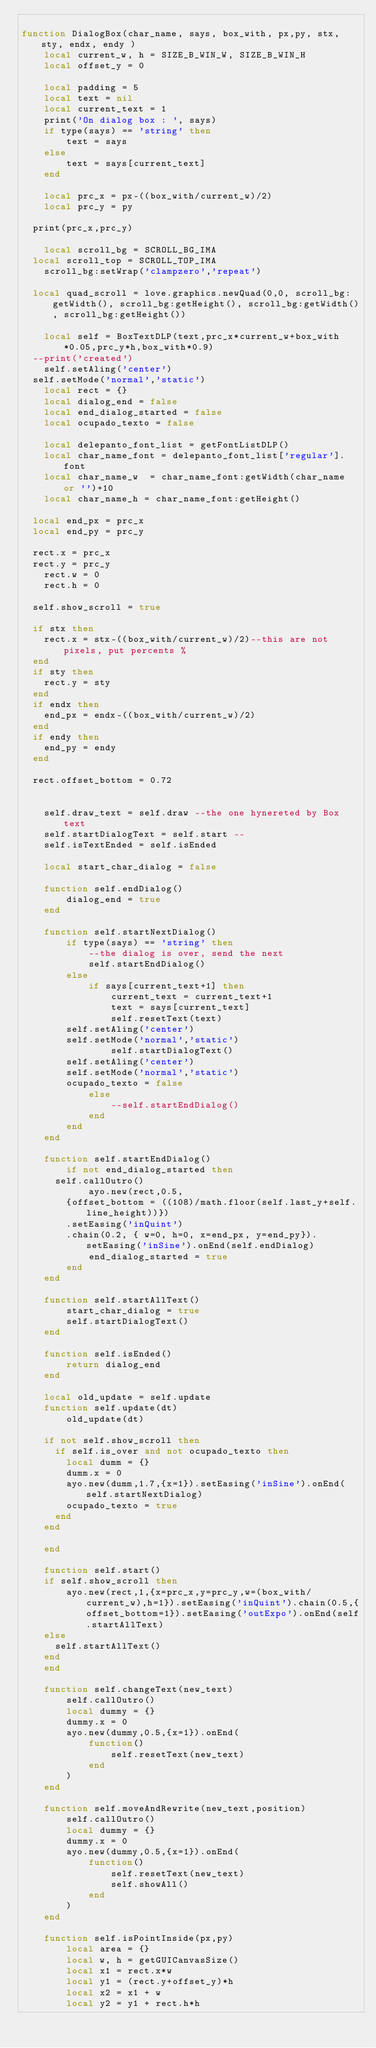Convert code to text. <code><loc_0><loc_0><loc_500><loc_500><_Lua_>
function DialogBox(char_name, says, box_with, px,py, stx, sty, endx, endy )
    local current_w, h = SIZE_B_WIN_W, SIZE_B_WIN_H
    local offset_y = 0
    
    local padding = 5
    local text = nil
    local current_text = 1
    print('On dialog box : ', says)
    if type(says) == 'string' then
        text = says
    else
        text = says[current_text]
    end
    
    local prc_x = px-((box_with/current_w)/2)
    local prc_y = py
    
	print(prc_x,prc_y)
	
    local scroll_bg = SCROLL_BG_IMA
	local scroll_top = SCROLL_TOP_IMA
    scroll_bg:setWrap('clampzero','repeat')
	
	local quad_scroll = love.graphics.newQuad(0,0, scroll_bg:getWidth(), scroll_bg:getHeight(), scroll_bg:getWidth(), scroll_bg:getHeight())
	
    local self = BoxTextDLP(text,prc_x*current_w+box_with*0.05,prc_y*h,box_with*0.9)
	--print('created')
    self.setAling('center')
	self.setMode('normal','static')
    local rect = {}
    local dialog_end = false 
    local end_dialog_started = false
    local ocupado_texto = false
	
    local delepanto_font_list = getFontListDLP()
    local char_name_font = delepanto_font_list['regular'].font
    local char_name_w  = char_name_font:getWidth(char_name or '')+10
    local char_name_h = char_name_font:getHeight()
    
	local end_px = prc_x
	local end_py = prc_y
	
	rect.x = prc_x 
	rect.y = prc_y
    rect.w = 0
    rect.h = 0
	
	self.show_scroll = true
	
	if stx then
		rect.x = stx-((box_with/current_w)/2)--this are not pixels, put percents %
	end
	if sty then
		rect.y = sty
	end
	if endx then
		end_px = endx-((box_with/current_w)/2)
	end
	if endy then
		end_py = endy
	end
	
	rect.offset_bottom = 0.72
	
	
    self.draw_text = self.draw --the one hynereted by Box text
    self.startDialogText = self.start --
    self.isTextEnded = self.isEnded

    local start_char_dialog = false

    function self.endDialog()
        dialog_end = true
    end
    
    function self.startNextDialog()
        if type(says) == 'string' then
            --the dialog is over, send the next
            self.startEndDialog()
        else
            if says[current_text+1] then
                current_text = current_text+1
                text = says[current_text]
                self.resetText(text)
				self.setAling('center')
				self.setMode('normal','static')
                self.startDialogText()
				self.setAling('center')
				self.setMode('normal','static')
				ocupado_texto = false
            else
                --self.startEndDialog()
            end
        end
    end
    
    function self.startEndDialog()
        if not end_dialog_started then
			self.callOutro()
            ayo.new(rect,0.5, 
				{offset_bottom = ((108)/math.floor(self.last_y+self.line_height))})
				.setEasing('inQuint')
				.chain(0.2, { w=0, h=0, x=end_px, y=end_py}).setEasing('inSine').onEnd(self.endDialog)
            end_dialog_started = true
        end
    end
    
    function self.startAllText()
        start_char_dialog = true
        self.startDialogText()
    end
    
    function self.isEnded()
        return dialog_end
    end
    
    local old_update = self.update
    function self.update(dt)
        old_update(dt)
		
		if not self.show_scroll then
			if self.is_over and not ocupado_texto then
				local dumm = {}
				dumm.x = 0
				ayo.new(dumm,1.7,{x=1}).setEasing('inSine').onEnd(self.startNextDialog)
				ocupado_texto = true
			end
		end
		
    end
    
    function self.start()
		if self.show_scroll then
        ayo.new(rect,1,{x=prc_x,y=prc_y,w=(box_with/current_w),h=1}).setEasing('inQuint').chain(0.5,{offset_bottom=1}).setEasing('outExpo').onEnd(self.startAllText)
		else
			self.startAllText()
		end
    end
    
    function self.changeText(new_text)
        self.callOutro()
        local dummy = {}
        dummy.x = 0
        ayo.new(dummy,0.5,{x=1}).onEnd(
            function()
                self.resetText(new_text)
            end
        )
    end
    
    function self.moveAndRewrite(new_text,position)
        self.callOutro()
        local dummy = {}
        dummy.x = 0
        ayo.new(dummy,0.5,{x=1}).onEnd(
            function()
                self.resetText(new_text)
                self.showAll()
            end
        )
    end
    
    function self.isPointInside(px,py)
        local area = {}
        local w, h = getGUICanvasSize()
        local x1 = rect.x*w
        local y1 = (rect.y+offset_y)*h
        local x2 = x1 + w
        local y2 = y1 + rect.h*h</code> 